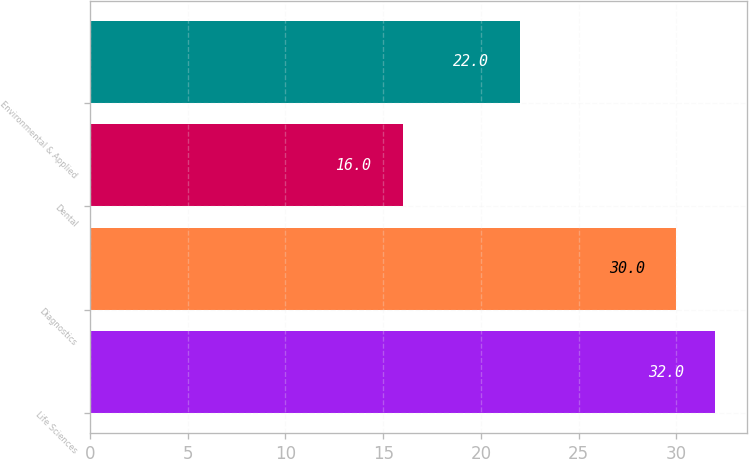<chart> <loc_0><loc_0><loc_500><loc_500><bar_chart><fcel>Life Sciences<fcel>Diagnostics<fcel>Dental<fcel>Environmental & Applied<nl><fcel>32<fcel>30<fcel>16<fcel>22<nl></chart> 